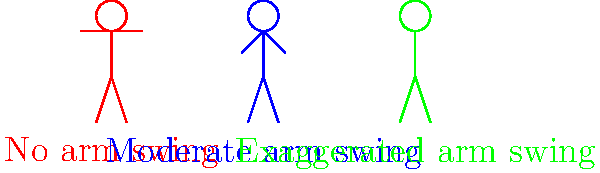Based on the stick figure animations shown above, which arm swing technique is likely to be most efficient for a distance runner, and why? To determine the most efficient arm swing technique for a distance runner, we need to consider several factors:

1. Energy Conservation: The primary goal in distance running is to conserve energy while maintaining speed.

2. Balance: Arm swing helps maintain balance during running, counteracting the rotation of the lower body.

3. Momentum: Proper arm swing can contribute to forward momentum.

4. Oxygen Efficiency: Arm position can affect breathing and oxygen intake.

Analyzing the three arm swing techniques shown:

a) No arm swing (red figure):
   - Conserves upper body energy
   - May lead to poor balance and reduced momentum
   - Could restrict chest expansion, affecting breathing

b) Moderate arm swing (blue figure):
   - Provides a balance between energy conservation and performance benefits
   - Helps maintain balance and contributes to forward momentum
   - Allows for natural chest expansion and breathing

c) Exaggerated arm swing (green figure):
   - Requires more energy expenditure
   - May provide excessive momentum, which is unnecessary for distance running
   - Could lead to upper body tension and inefficient oxygen use

Considering these factors, the moderate arm swing (blue figure) is likely to be the most efficient for a distance runner. It provides the benefits of improved balance and momentum without excessive energy expenditure, making it ideal for long-distance events where energy conservation is crucial.
Answer: Moderate arm swing (blue figure) 